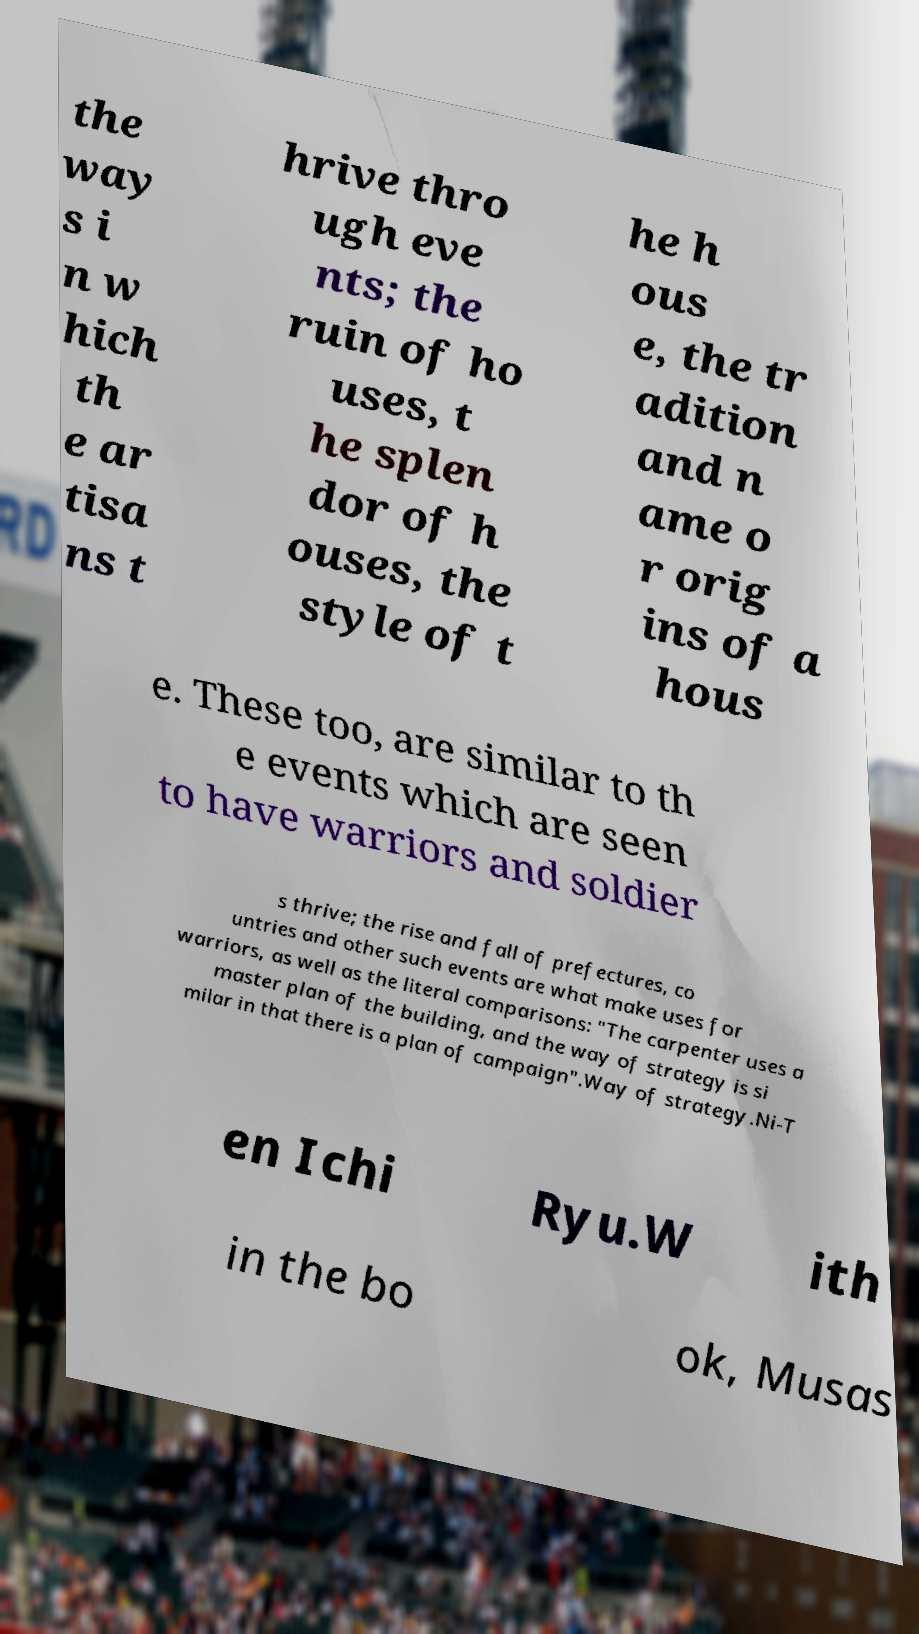Please identify and transcribe the text found in this image. the way s i n w hich th e ar tisa ns t hrive thro ugh eve nts; the ruin of ho uses, t he splen dor of h ouses, the style of t he h ous e, the tr adition and n ame o r orig ins of a hous e. These too, are similar to th e events which are seen to have warriors and soldier s thrive; the rise and fall of prefectures, co untries and other such events are what make uses for warriors, as well as the literal comparisons: "The carpenter uses a master plan of the building, and the way of strategy is si milar in that there is a plan of campaign".Way of strategy.Ni-T en Ichi Ryu.W ith in the bo ok, Musas 